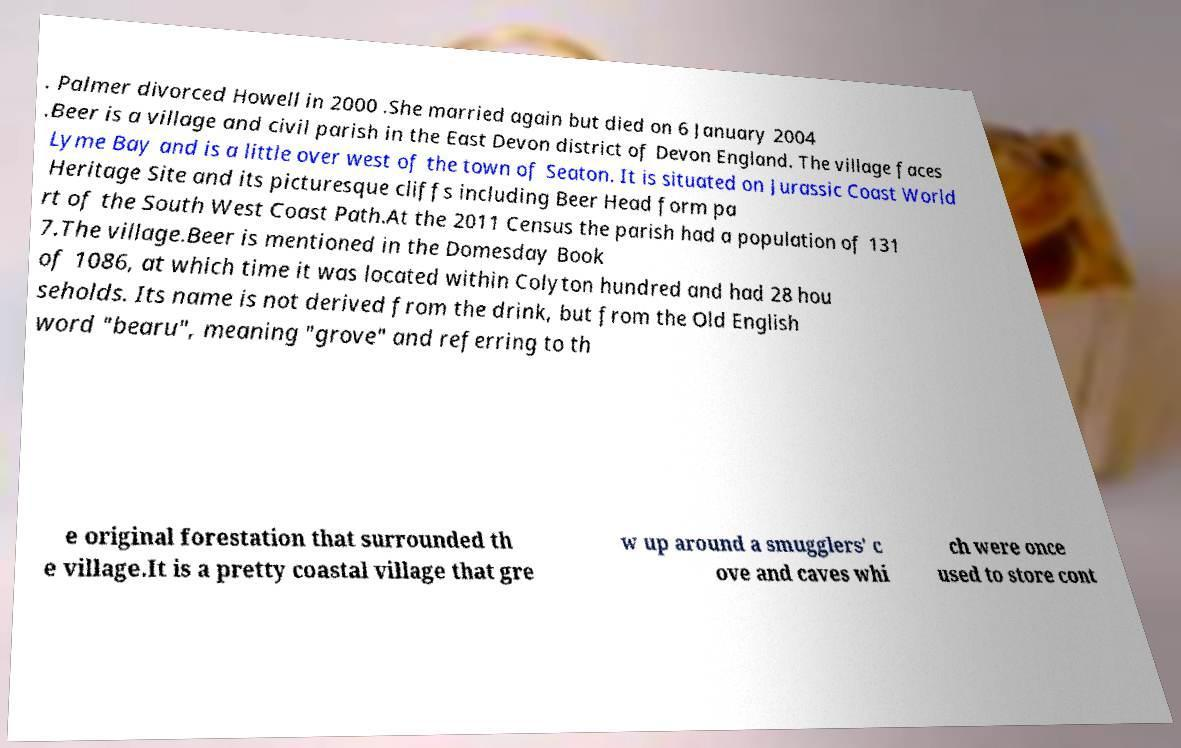Could you assist in decoding the text presented in this image and type it out clearly? . Palmer divorced Howell in 2000 .She married again but died on 6 January 2004 .Beer is a village and civil parish in the East Devon district of Devon England. The village faces Lyme Bay and is a little over west of the town of Seaton. It is situated on Jurassic Coast World Heritage Site and its picturesque cliffs including Beer Head form pa rt of the South West Coast Path.At the 2011 Census the parish had a population of 131 7.The village.Beer is mentioned in the Domesday Book of 1086, at which time it was located within Colyton hundred and had 28 hou seholds. Its name is not derived from the drink, but from the Old English word "bearu", meaning "grove" and referring to th e original forestation that surrounded th e village.It is a pretty coastal village that gre w up around a smugglers' c ove and caves whi ch were once used to store cont 